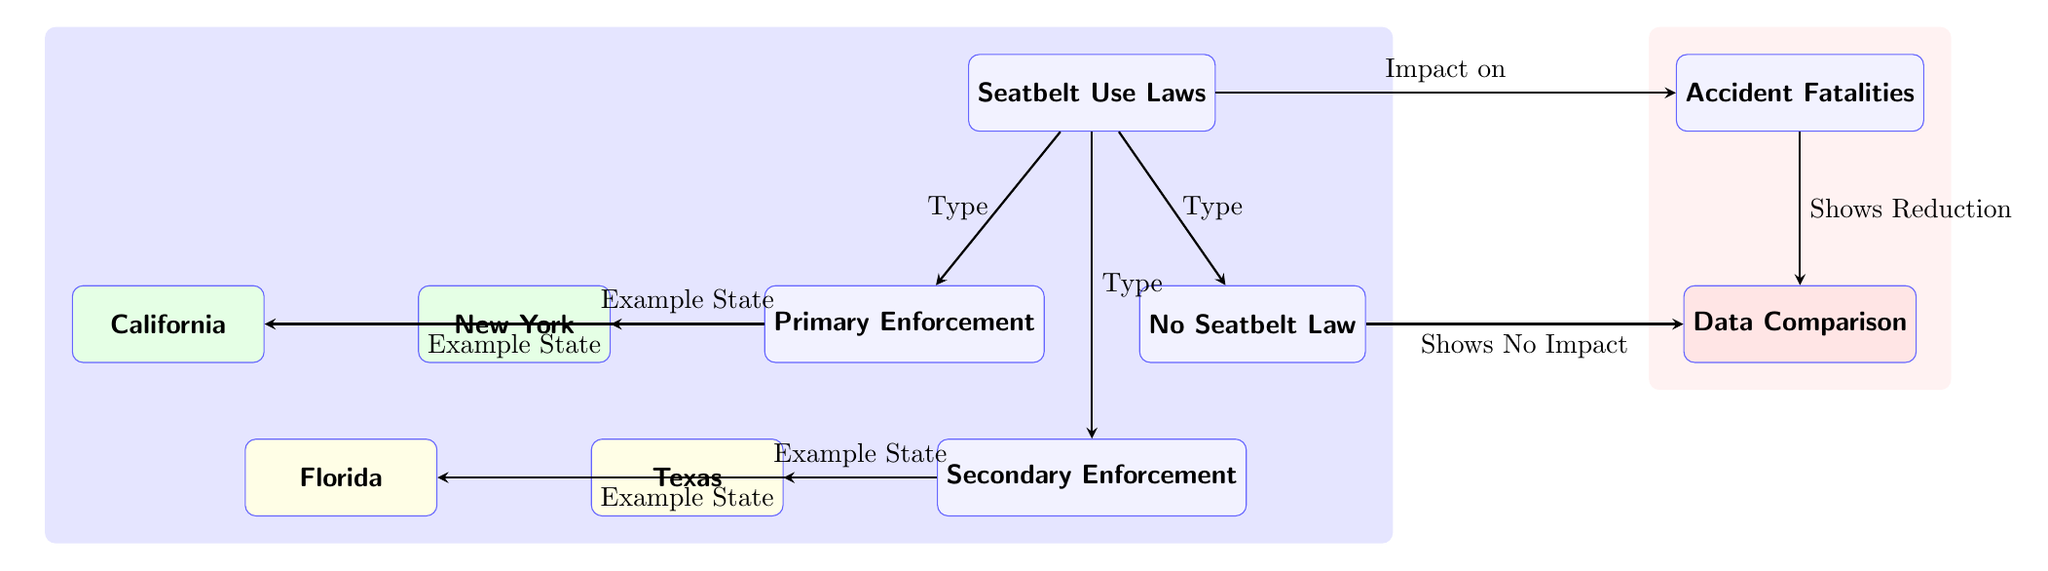What are the three types of seatbelt laws depicted? The diagram displays three types of seatbelt laws: Primary Enforcement, Secondary Enforcement, and No Seatbelt Law. These are listed directly under the main node labeled "Seatbelt Use Laws."
Answer: Primary Enforcement, Secondary Enforcement, No Seatbelt Law Which two states are examples of primary enforcement? The diagram lists two states under the Primary Enforcement node: New York and California. This information is shown as sub-nodes stemming from Primary Enforcement.
Answer: New York, California What does the arrow from "Seatbelt Use Laws" to "Accident Fatalities" indicate? The arrow signifies that the type of seatbelt law has an impact on accident fatalities, as noted in the label above the arrow connecting these two nodes.
Answer: Impact on How many example states are given for secondary enforcement? Under the Secondary Enforcement node, there are two example states listed: Texas and Florida. This is indicated by sub-nodes under the Secondary Enforcement node.
Answer: 2 What type of seatbelt law is associated with a reduction in fatalities? The diagram indicates that primary and secondary enforcement laws are correlated with the reduction in accident fatalities, as shown by the arrow pointing to the data comparison node labeled "Shows Reduction."
Answer: Primary and Secondary Enforcement What does the label "Shows No Impact" refer to in the diagram? The label "Shows No Impact" is associated with the arrow originating from the "No Seatbelt Law" node, indicating that this type of law does not reduce accident fatalities, as depicted in the diagram.
Answer: No Seatbelt Law How does the diagram organize the information visually? The diagram uses a hierarchical structure with nodes representing different elements of the relationship between seatbelt laws and accident fatalities, showcasing the enforcement type and correlating example states, thereby allowing for a visual comparison.
Answer: Hierarchical structure What color represents example states with primary enforcement? The example states for primary enforcement (New York and California) are represented in green, which is indicated by the fill color specified for these nodes in the diagram.
Answer: Green 